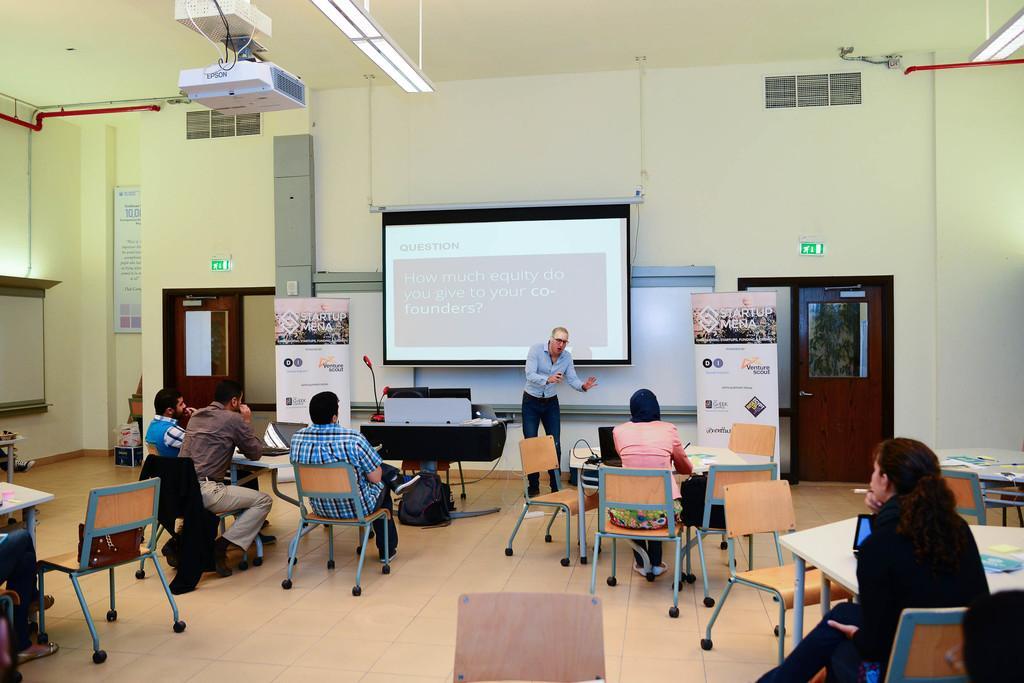In one or two sentences, can you explain what this image depicts? In this image few people are sitting on the chair. On the table there is laptop. In front the person is standing. At the back side there is screen,board and a wall. There is a door. 